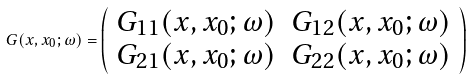Convert formula to latex. <formula><loc_0><loc_0><loc_500><loc_500>G ( x , x _ { 0 } ; \omega ) = \left ( \begin{array} { c c } G _ { 1 1 } ( x , x _ { 0 } ; \omega ) & G _ { 1 2 } ( x , x _ { 0 } ; \omega ) \\ G _ { 2 1 } ( x , x _ { 0 } ; \omega ) & G _ { 2 2 } ( x , x _ { 0 } ; \omega ) \end{array} \right ) \begin{array} { c c } & \\ & \end{array}</formula> 